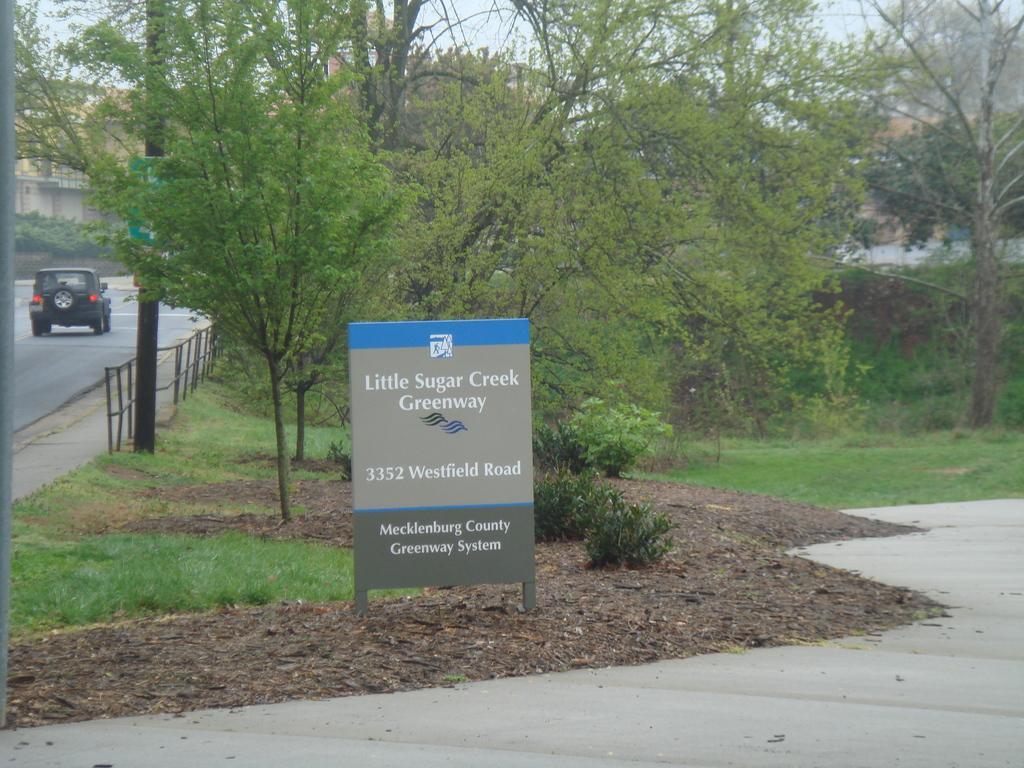How would you summarize this image in a sentence or two? In this picture there is a board in the foreground and there is text on the board. At the back there are trees and buildings and there is a vehicle on the road and there is a railing and there are poles and there is a board on the pole. At the top there is sky. At the bottom there is a road and there is ground and grass and there are dried leaves. 